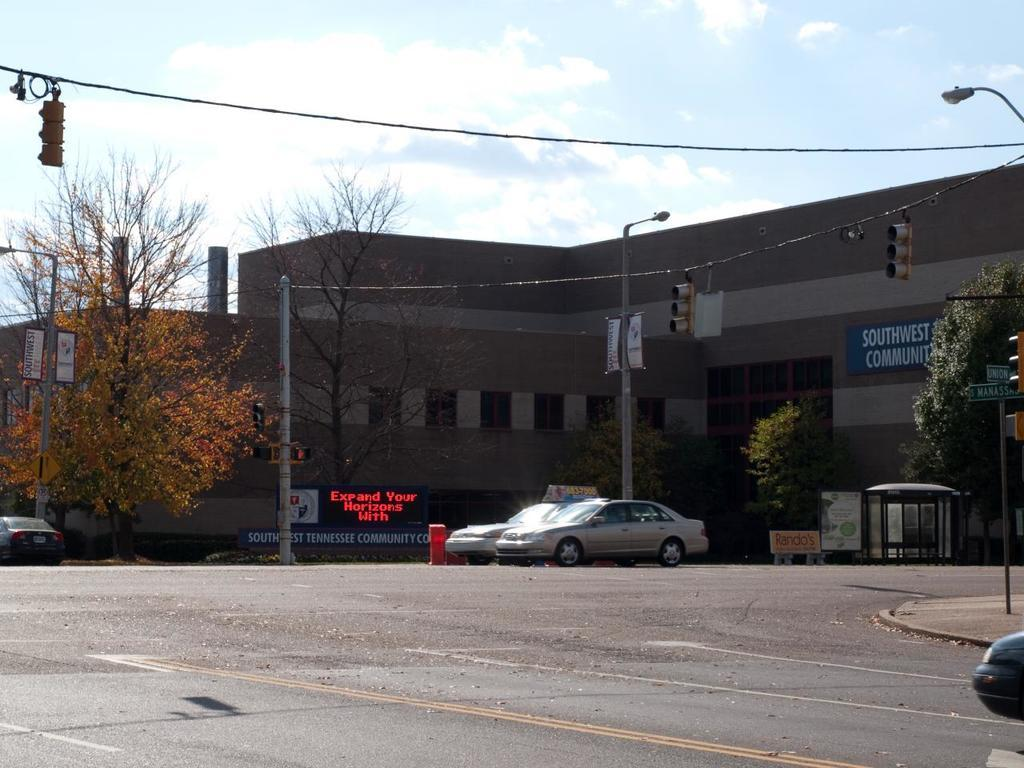What is located at the bottom of the image? There is a road at the bottom of the image. What can be seen on the road? There are cars on the road. What type of vegetation is on the left side of the image? There are trees on the left side of the image. What type of structure is present in the image? There is a building in the image. What is visible at the top of the image? The sky is visible at the top of the image. What type of yoke is being used by the mind in the image? There is no yoke or mind present in the image; it features a road, cars, trees, a building, and the sky. What type of dish is the cook preparing in the image? There is no cook or dish preparation present in the image. 